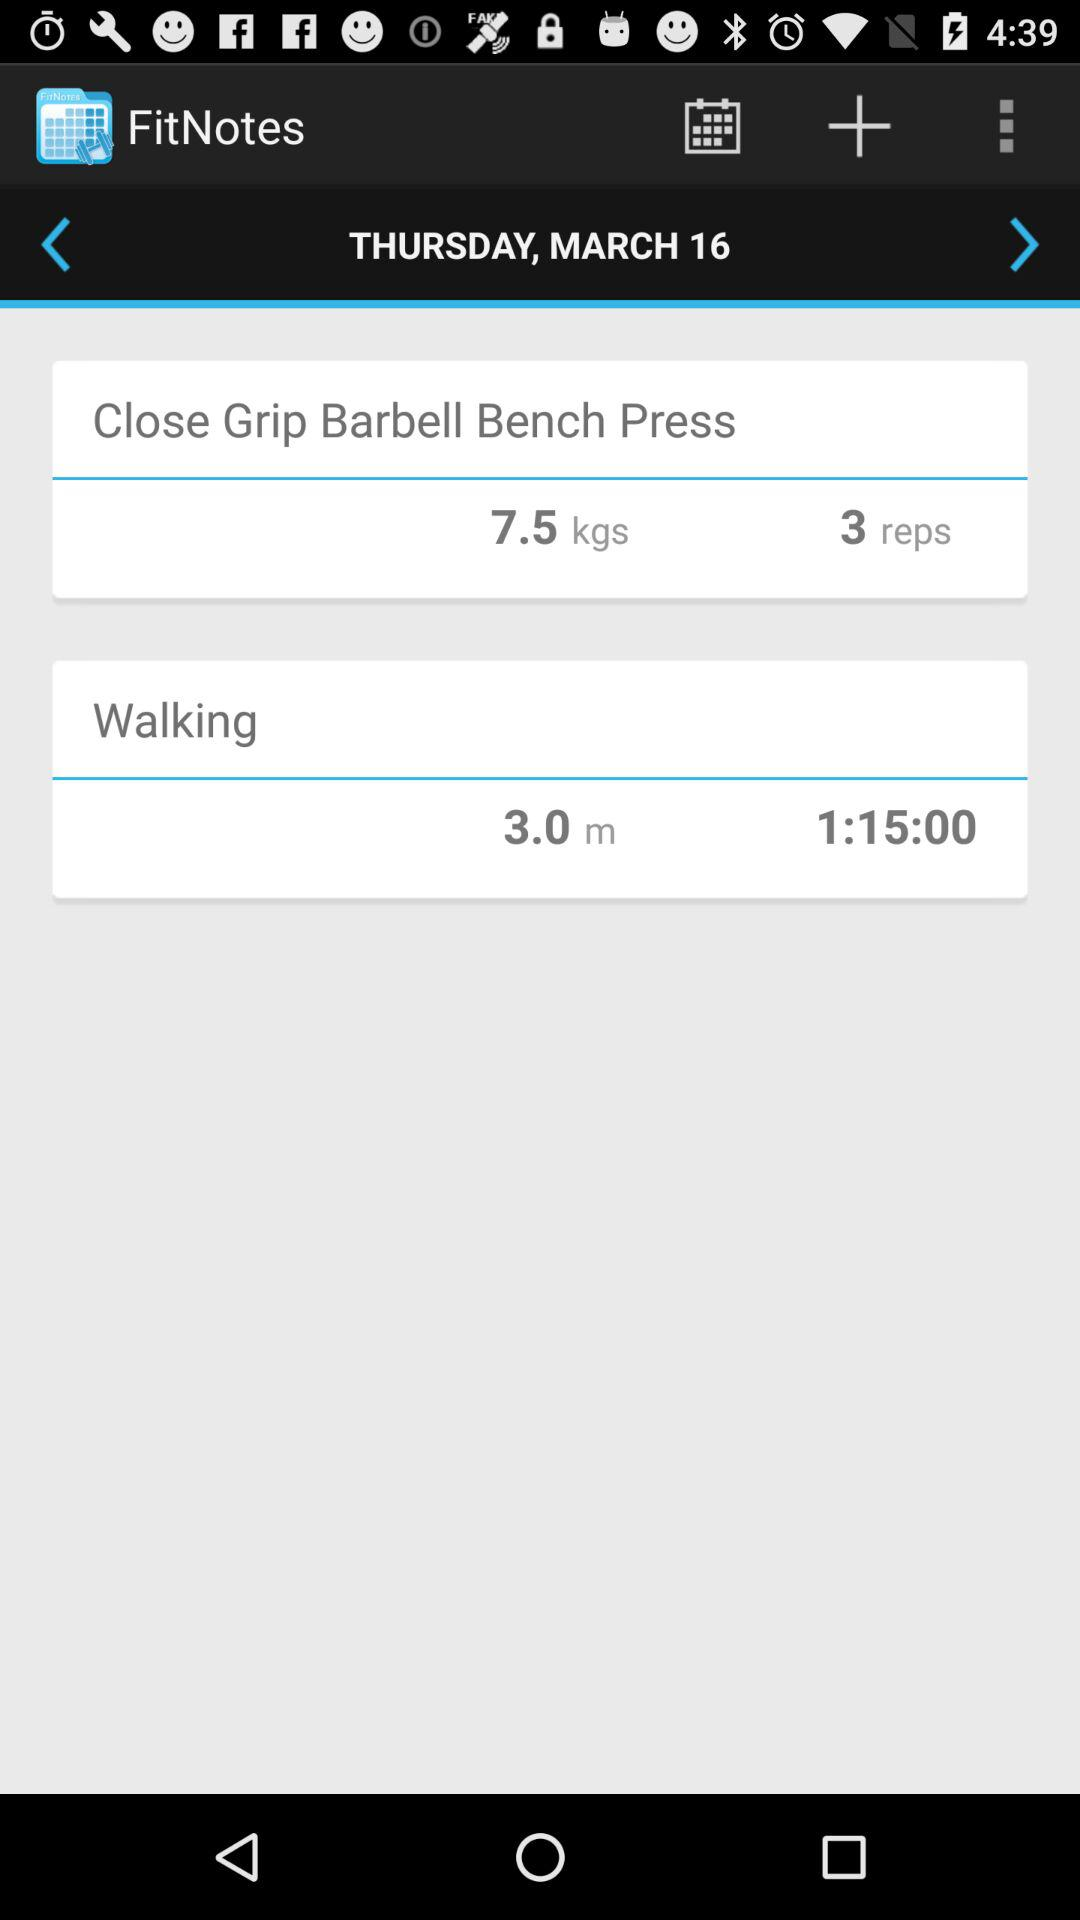What is the selected date? The selected date is Thursday, March 16. 